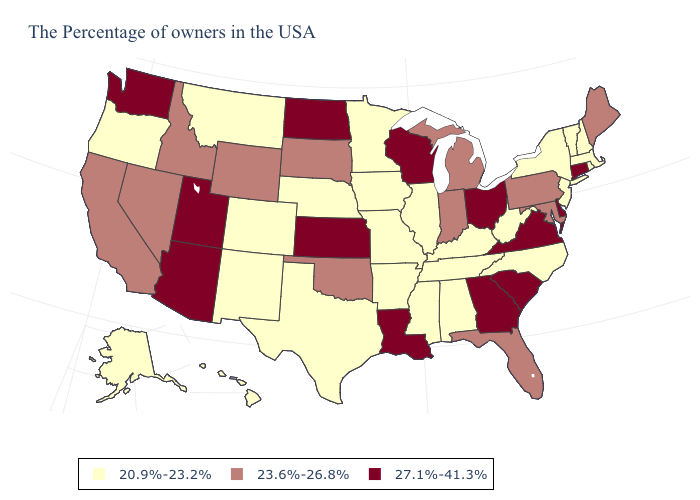Name the states that have a value in the range 20.9%-23.2%?
Keep it brief. Massachusetts, Rhode Island, New Hampshire, Vermont, New York, New Jersey, North Carolina, West Virginia, Kentucky, Alabama, Tennessee, Illinois, Mississippi, Missouri, Arkansas, Minnesota, Iowa, Nebraska, Texas, Colorado, New Mexico, Montana, Oregon, Alaska, Hawaii. Name the states that have a value in the range 20.9%-23.2%?
Write a very short answer. Massachusetts, Rhode Island, New Hampshire, Vermont, New York, New Jersey, North Carolina, West Virginia, Kentucky, Alabama, Tennessee, Illinois, Mississippi, Missouri, Arkansas, Minnesota, Iowa, Nebraska, Texas, Colorado, New Mexico, Montana, Oregon, Alaska, Hawaii. Among the states that border Wisconsin , which have the lowest value?
Quick response, please. Illinois, Minnesota, Iowa. Does Idaho have the lowest value in the USA?
Write a very short answer. No. Is the legend a continuous bar?
Answer briefly. No. What is the lowest value in the USA?
Keep it brief. 20.9%-23.2%. What is the lowest value in states that border Washington?
Answer briefly. 20.9%-23.2%. What is the lowest value in the USA?
Write a very short answer. 20.9%-23.2%. What is the value of Kansas?
Give a very brief answer. 27.1%-41.3%. Does South Carolina have the highest value in the USA?
Write a very short answer. Yes. Does the map have missing data?
Concise answer only. No. What is the value of Washington?
Concise answer only. 27.1%-41.3%. Does Tennessee have a higher value than California?
Short answer required. No. Name the states that have a value in the range 20.9%-23.2%?
Keep it brief. Massachusetts, Rhode Island, New Hampshire, Vermont, New York, New Jersey, North Carolina, West Virginia, Kentucky, Alabama, Tennessee, Illinois, Mississippi, Missouri, Arkansas, Minnesota, Iowa, Nebraska, Texas, Colorado, New Mexico, Montana, Oregon, Alaska, Hawaii. What is the value of Minnesota?
Quick response, please. 20.9%-23.2%. 